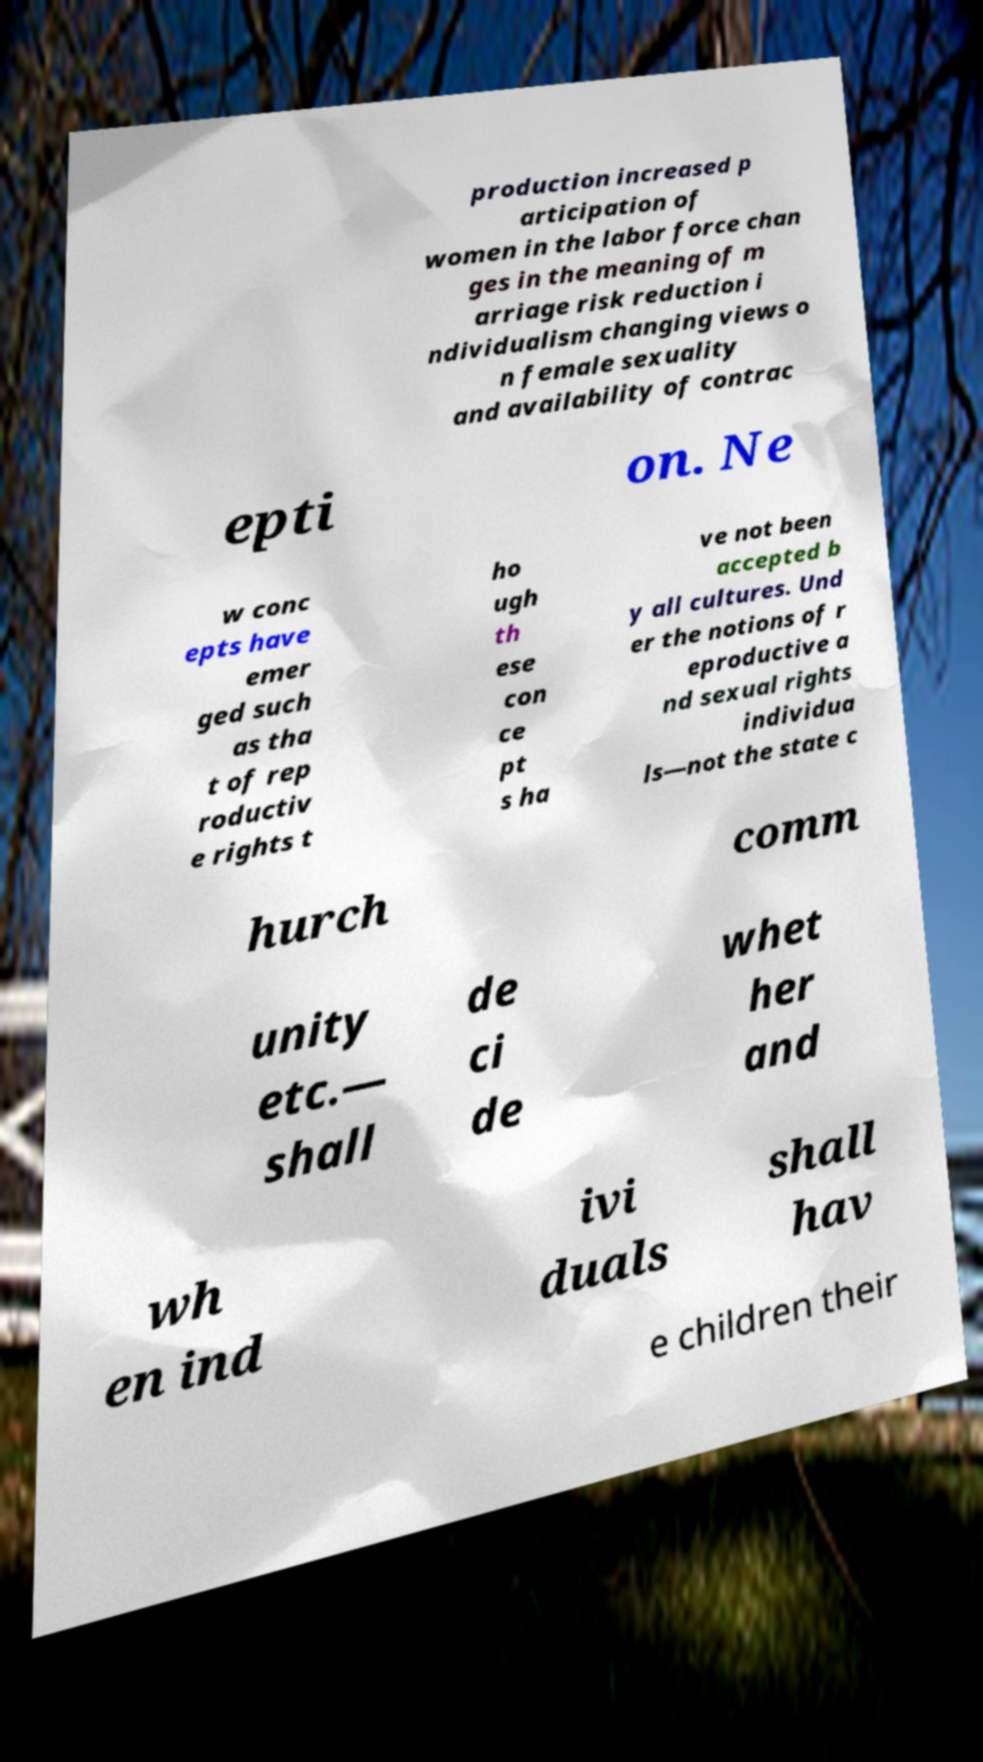What messages or text are displayed in this image? I need them in a readable, typed format. production increased p articipation of women in the labor force chan ges in the meaning of m arriage risk reduction i ndividualism changing views o n female sexuality and availability of contrac epti on. Ne w conc epts have emer ged such as tha t of rep roductiv e rights t ho ugh th ese con ce pt s ha ve not been accepted b y all cultures. Und er the notions of r eproductive a nd sexual rights individua ls—not the state c hurch comm unity etc.— shall de ci de whet her and wh en ind ivi duals shall hav e children their 